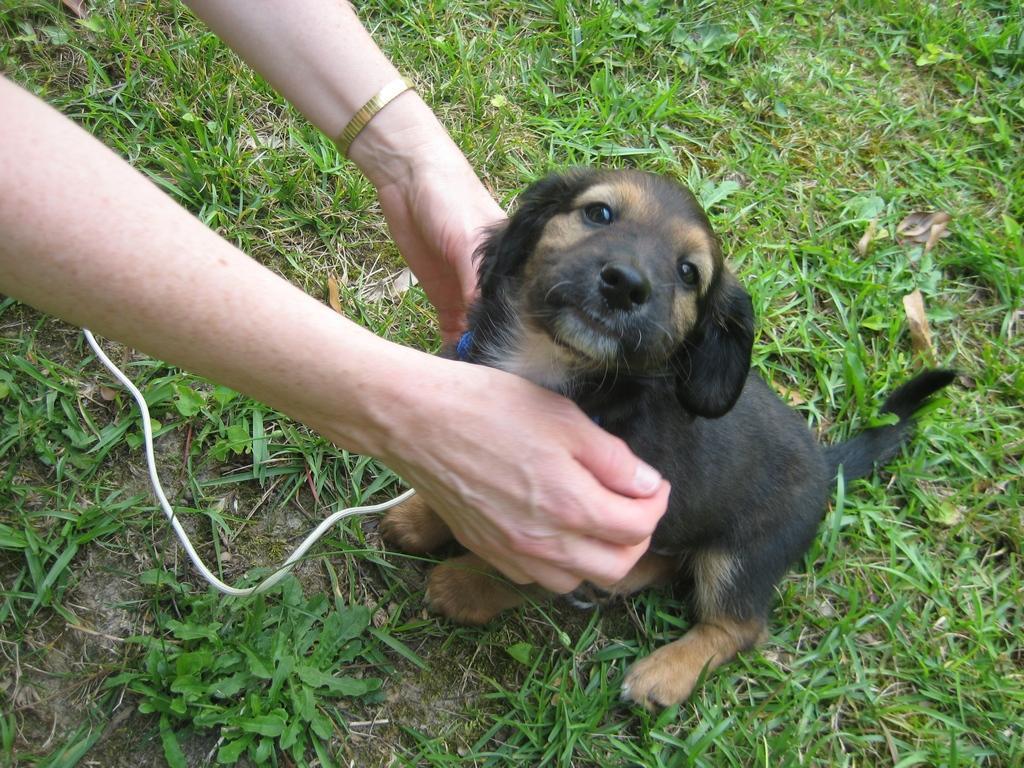In one or two sentences, can you explain what this image depicts? In the image in the center,we can see one person holding dog,which is in brown and black color. In the background we can see grass and wire. 